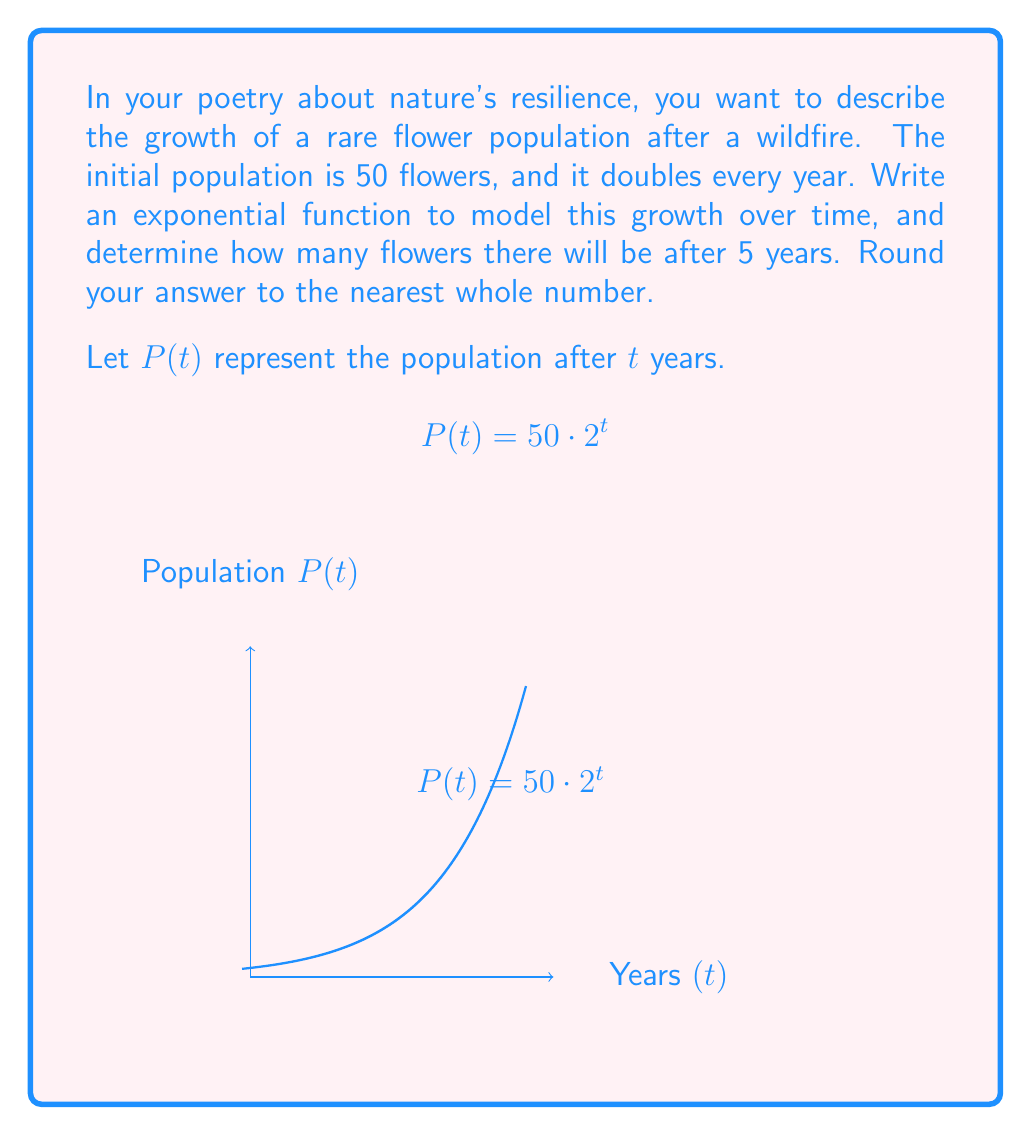Teach me how to tackle this problem. Let's approach this step-by-step:

1) We're given that the initial population is 50 flowers and it doubles every year. This is a perfect scenario for an exponential function.

2) The general form of an exponential function is:
   $$P(t) = P_0 \cdot b^t$$
   where $P_0$ is the initial population, $b$ is the growth factor, and $t$ is time.

3) In this case:
   - $P_0 = 50$ (initial population)
   - $b = 2$ (doubles each year, so growth factor is 2)

4) Substituting these values into the general form:
   $$P(t) = 50 \cdot 2^t$$

5) To find the population after 5 years, we substitute $t = 5$:
   $$P(5) = 50 \cdot 2^5$$

6) Calculate:
   $$P(5) = 50 \cdot 32 = 1600$$

7) The question asks to round to the nearest whole number, but 1600 is already a whole number.

Therefore, after 5 years, there will be 1600 flowers.
Answer: 1600 flowers 